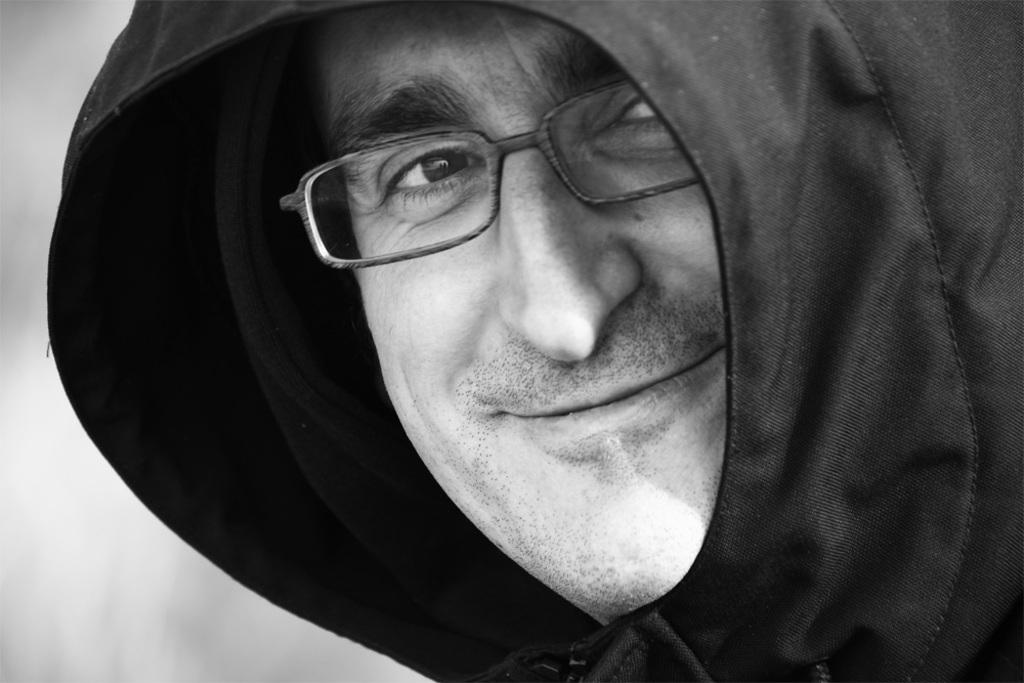What is present in the image? There is a person in the image. How is the person's facial expression? The person is smiling. What type of clothing is the person wearing? The person is wearing a jacket. What type of stick is the baby holding in the image? There is no baby or stick present in the image; it only features a person wearing a jacket and smiling. 